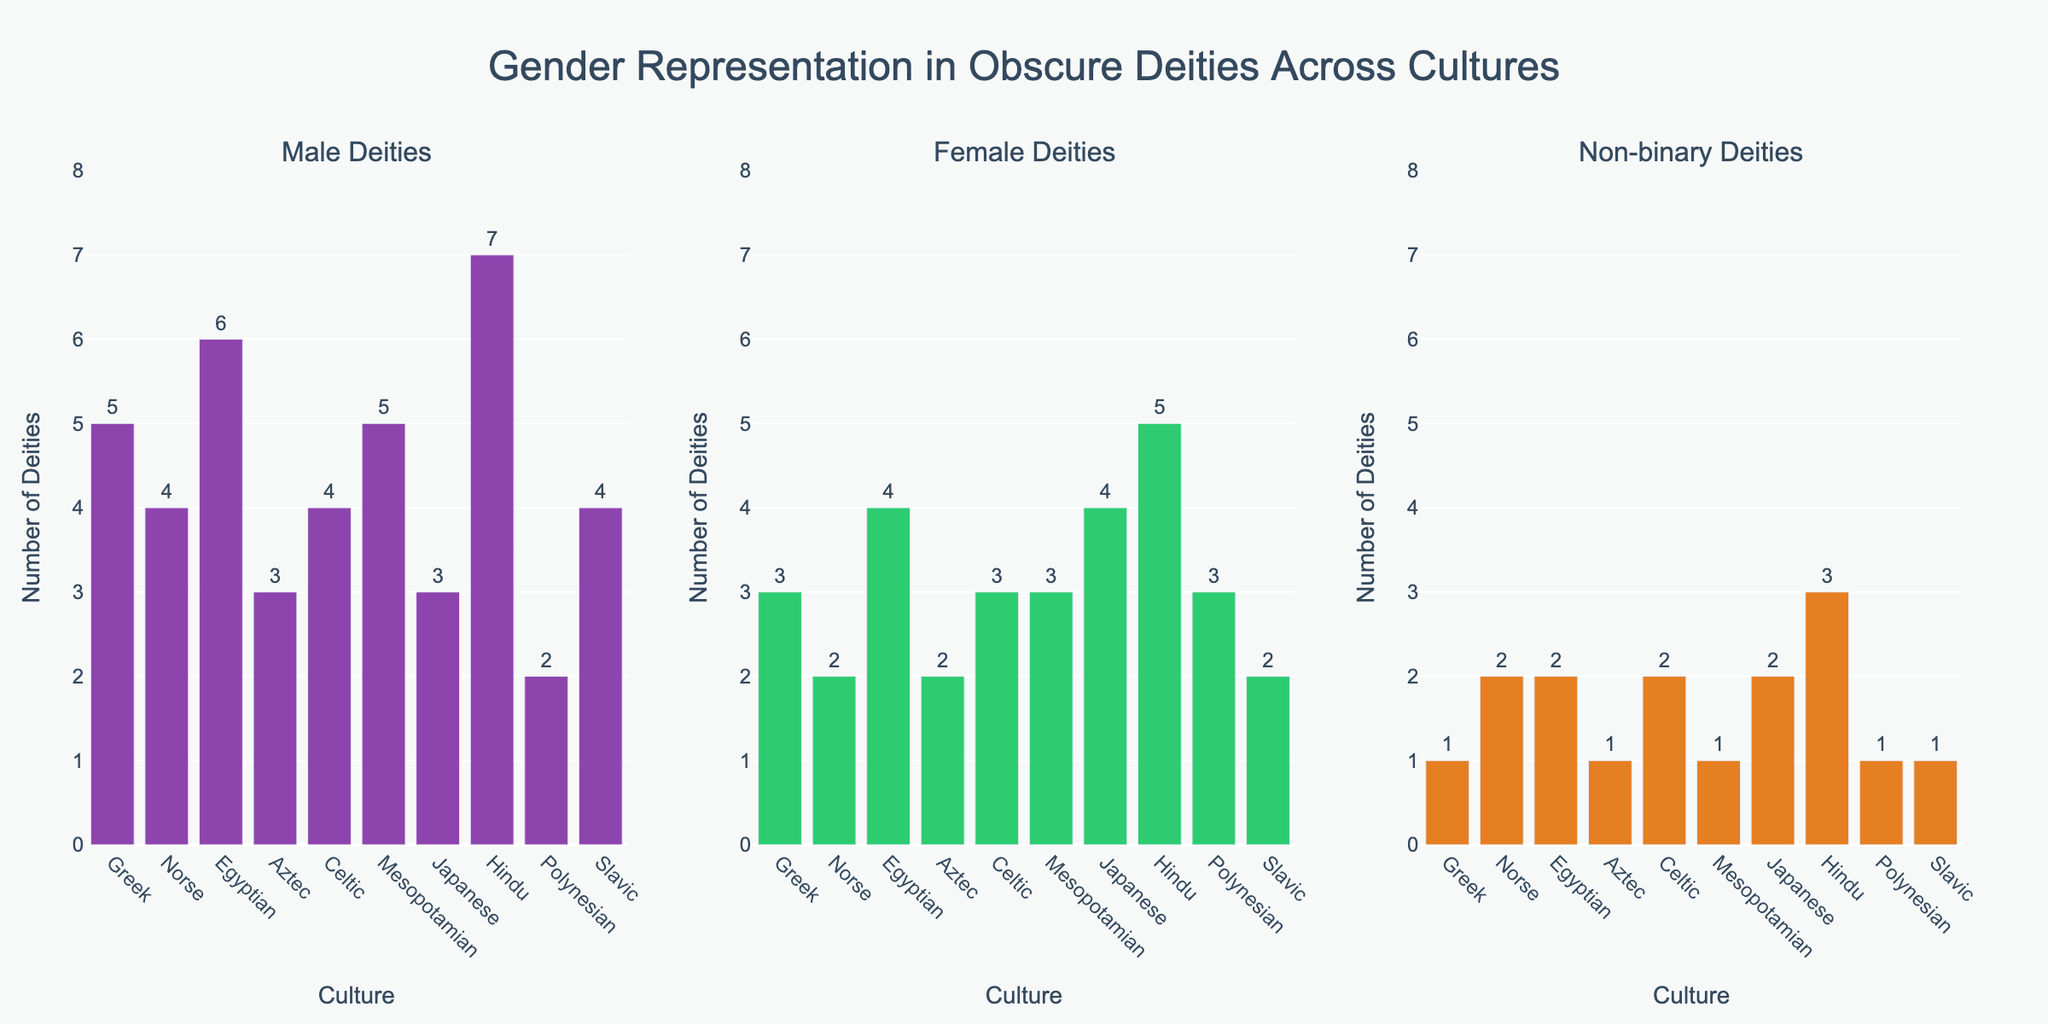What's the title of the figure? The title is displayed at the top of the figure and summarizes the overall content, which is "Gender Representation in Obscure Deities Across Cultures".
Answer: Gender Representation in Obscure Deities Across Cultures How many male deities are there in the Greek pantheon? By looking at the bar corresponding to "Male Deities" for the Greek culture, the height of the bar indicates the number, which is labeled next to the bar.
Answer: 5 Which culture has the most female deities represented? Count the heights of bars for each culture in the "Female Deities" subplot. The highest bar represents the culture with the most female deities.
Answer: Hindu What's the total number of deities (male, female, and non-binary) in the Aztec pantheon? Sum the values of male, female, and non-binary deities for the Aztec culture. The values are 3 (male), 2 (female), and 1 (non-binary), so the total is 3 + 2 + 1.
Answer: 6 Which culture has the highest number of non-binary deities? By comparing the heights of the bars in the "Non-binary Deities" subplot, the highest bar indicates the culture with the most non-binary deities.
Answer: Hindu How many more female deities are there than male deities in the Japanese pantheon? Subtract the number of male deities from the number of female deities in the Japanese culture, which are 4 (female) and 3 (male). 4 - 3 = 1.
Answer: 1 Which culture has the least number of male deities? Identify the shortest bar in the "Male Deities" subplot which represents the culture with the least male deities.
Answer: Polynesian How many non-binary and female deities combined are there in the Norse pantheon? Add the number of non-binary (2) and female deities (2) in the Norse culture. 2 + 2 = 4.
Answer: 4 What's the average number of male deities across all cultures? Sum all the male deities in each culture and divide by the number of cultures. (5+4+6+3+4+5+3+7+2+4)/10 = 4.3.
Answer: 4.3 